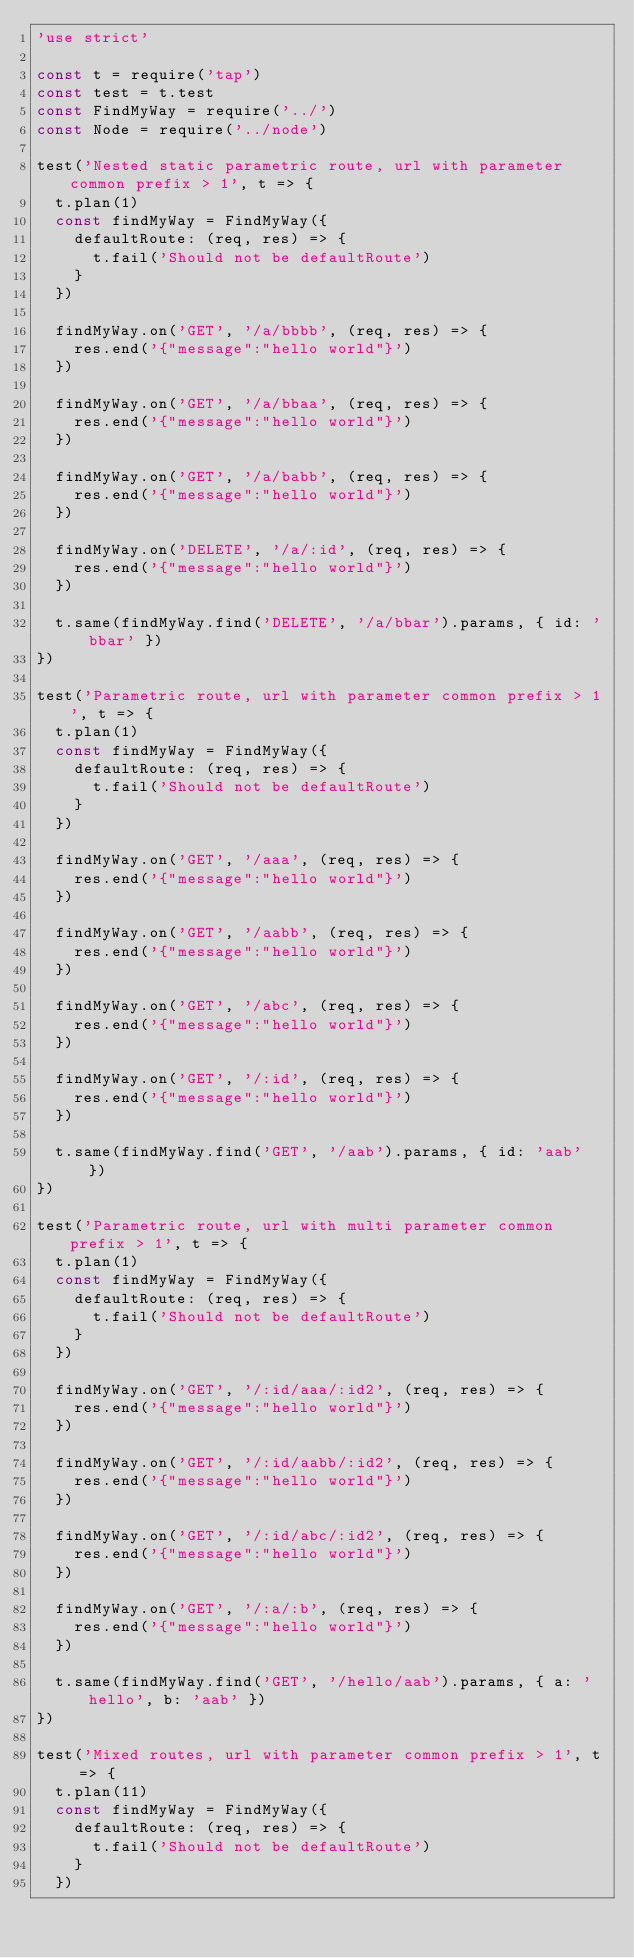Convert code to text. <code><loc_0><loc_0><loc_500><loc_500><_JavaScript_>'use strict'

const t = require('tap')
const test = t.test
const FindMyWay = require('../')
const Node = require('../node')

test('Nested static parametric route, url with parameter common prefix > 1', t => {
  t.plan(1)
  const findMyWay = FindMyWay({
    defaultRoute: (req, res) => {
      t.fail('Should not be defaultRoute')
    }
  })

  findMyWay.on('GET', '/a/bbbb', (req, res) => {
    res.end('{"message":"hello world"}')
  })

  findMyWay.on('GET', '/a/bbaa', (req, res) => {
    res.end('{"message":"hello world"}')
  })

  findMyWay.on('GET', '/a/babb', (req, res) => {
    res.end('{"message":"hello world"}')
  })

  findMyWay.on('DELETE', '/a/:id', (req, res) => {
    res.end('{"message":"hello world"}')
  })

  t.same(findMyWay.find('DELETE', '/a/bbar').params, { id: 'bbar' })
})

test('Parametric route, url with parameter common prefix > 1', t => {
  t.plan(1)
  const findMyWay = FindMyWay({
    defaultRoute: (req, res) => {
      t.fail('Should not be defaultRoute')
    }
  })

  findMyWay.on('GET', '/aaa', (req, res) => {
    res.end('{"message":"hello world"}')
  })

  findMyWay.on('GET', '/aabb', (req, res) => {
    res.end('{"message":"hello world"}')
  })

  findMyWay.on('GET', '/abc', (req, res) => {
    res.end('{"message":"hello world"}')
  })

  findMyWay.on('GET', '/:id', (req, res) => {
    res.end('{"message":"hello world"}')
  })

  t.same(findMyWay.find('GET', '/aab').params, { id: 'aab' })
})

test('Parametric route, url with multi parameter common prefix > 1', t => {
  t.plan(1)
  const findMyWay = FindMyWay({
    defaultRoute: (req, res) => {
      t.fail('Should not be defaultRoute')
    }
  })

  findMyWay.on('GET', '/:id/aaa/:id2', (req, res) => {
    res.end('{"message":"hello world"}')
  })

  findMyWay.on('GET', '/:id/aabb/:id2', (req, res) => {
    res.end('{"message":"hello world"}')
  })

  findMyWay.on('GET', '/:id/abc/:id2', (req, res) => {
    res.end('{"message":"hello world"}')
  })

  findMyWay.on('GET', '/:a/:b', (req, res) => {
    res.end('{"message":"hello world"}')
  })

  t.same(findMyWay.find('GET', '/hello/aab').params, { a: 'hello', b: 'aab' })
})

test('Mixed routes, url with parameter common prefix > 1', t => {
  t.plan(11)
  const findMyWay = FindMyWay({
    defaultRoute: (req, res) => {
      t.fail('Should not be defaultRoute')
    }
  })
</code> 